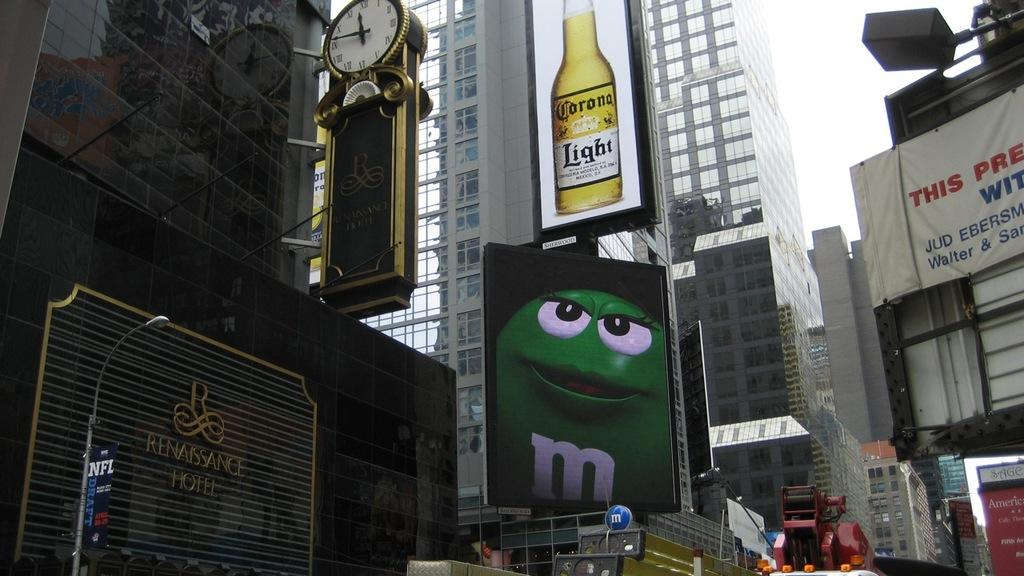Provide a one-sentence caption for the provided image. An urban city with a large advert for Corona Light. 